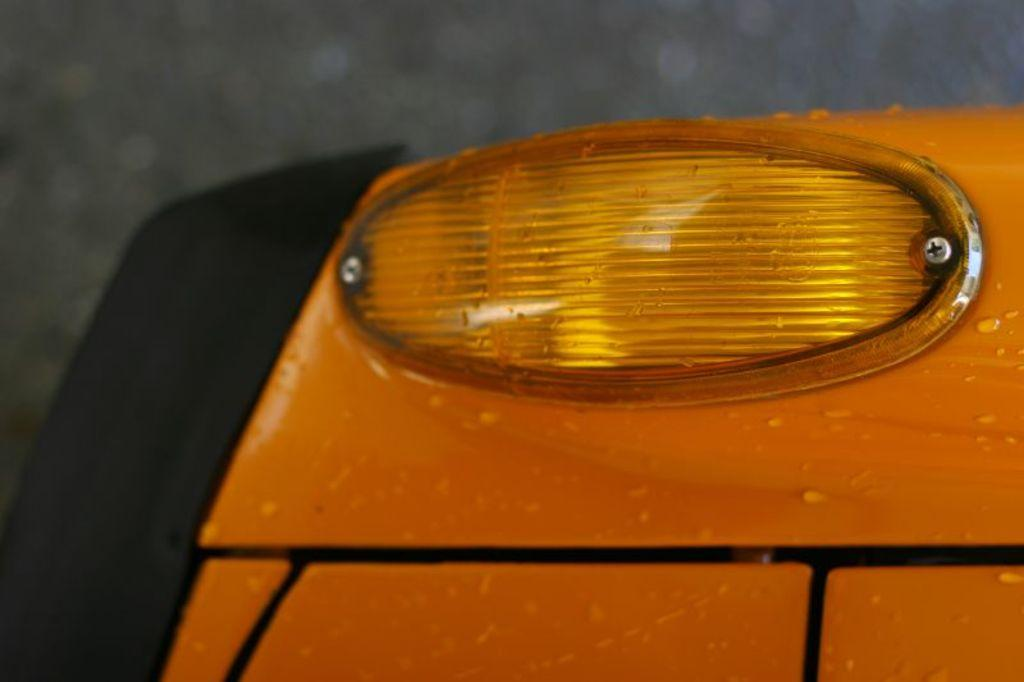What is the main object in the image? There is a headlight in the image. What type of shock can be seen coming from the headlight in the image? There is no shock present in the image; it only features a headlight. What scientific theory is being demonstrated by the headlight in the image? There is no scientific theory being demonstrated in the image; it only features a headlight. 